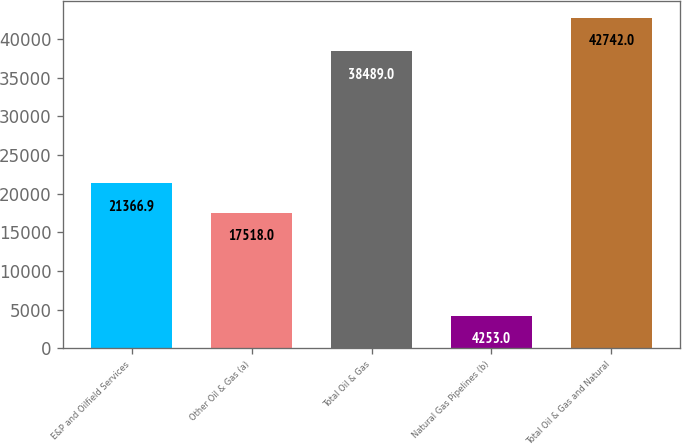<chart> <loc_0><loc_0><loc_500><loc_500><bar_chart><fcel>E&P and Oilfield Services<fcel>Other Oil & Gas (a)<fcel>Total Oil & Gas<fcel>Natural Gas Pipelines (b)<fcel>Total Oil & Gas and Natural<nl><fcel>21366.9<fcel>17518<fcel>38489<fcel>4253<fcel>42742<nl></chart> 